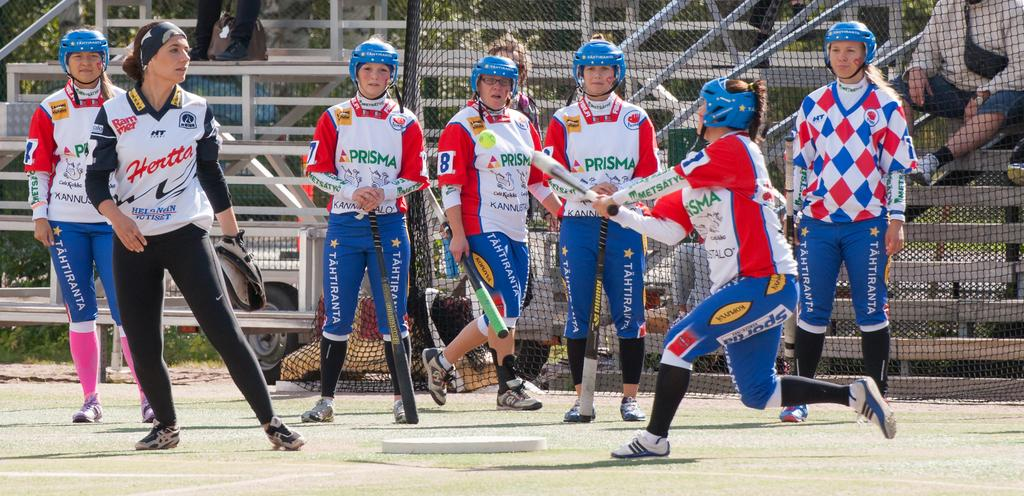<image>
Summarize the visual content of the image. women in sports uniforms saying Prisma are hitting a ball in a field 